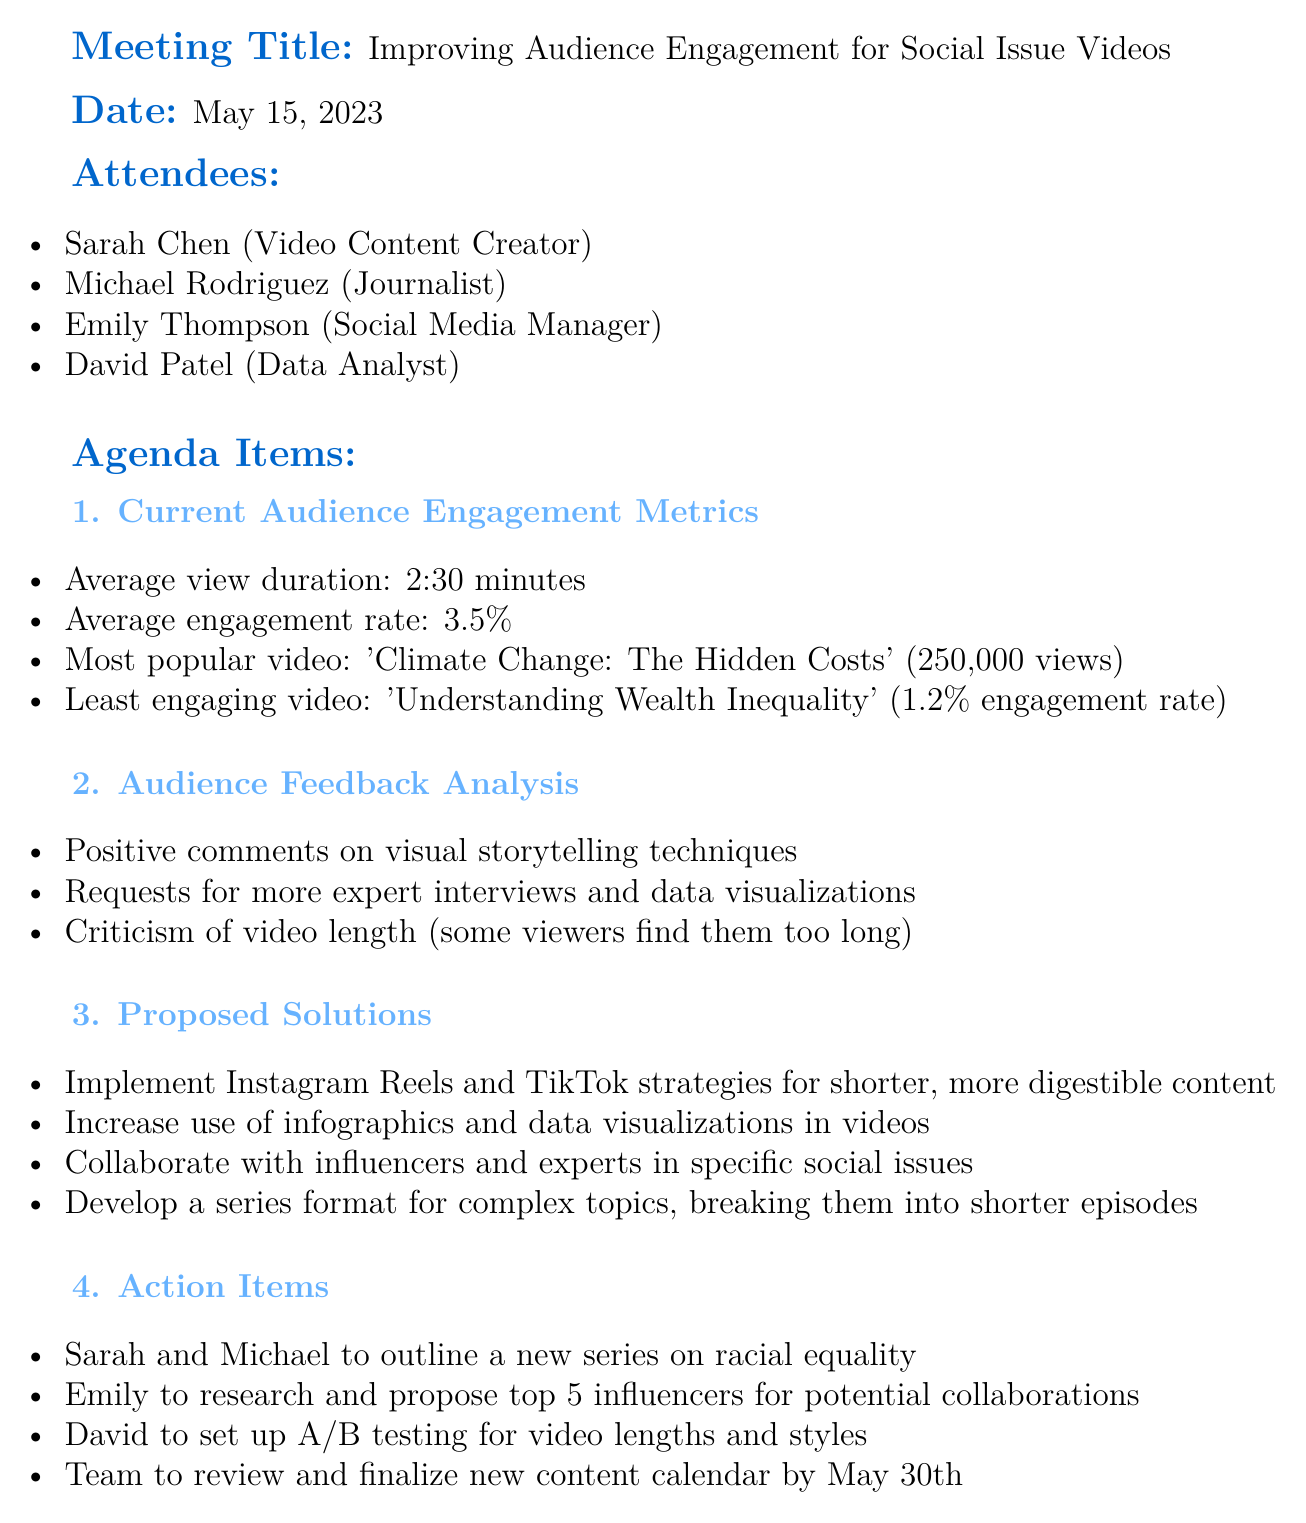What is the meeting title? The meeting title is stated at the beginning of the document.
Answer: Improving Audience Engagement for Social Issue Videos What is the date of the meeting? The date is mentioned following the meeting title in the document.
Answer: May 15, 2023 Who are the attendees of the meeting? The list of attendees is provided under the Attendees section.
Answer: Sarah Chen, Michael Rodriguez, Emily Thompson, David Patel What is the average view duration? The average view duration is mentioned under Current Audience Engagement Metrics.
Answer: 2:30 minutes What is the least engaging video? The least engaging video is listed in the Current Audience Engagement Metrics section.
Answer: Understanding Wealth Inequality What feedback did viewers provide regarding video length? This feedback is included in the Audience Feedback Analysis.
Answer: Some viewers find them too long How many proposals are listed under Proposed Solutions? The number of proposals can be counted in the Proposed Solutions section of the document.
Answer: 4 What is one action item assigned to David? The action items specify tasks for each attendee.
Answer: Set up A/B testing for video lengths and styles Which social media strategies are proposed for audience engagement? Proposed strategies are outlined under Proposed Solutions, specifically mentioning social media platforms.
Answer: Instagram Reels and TikTok strategies 